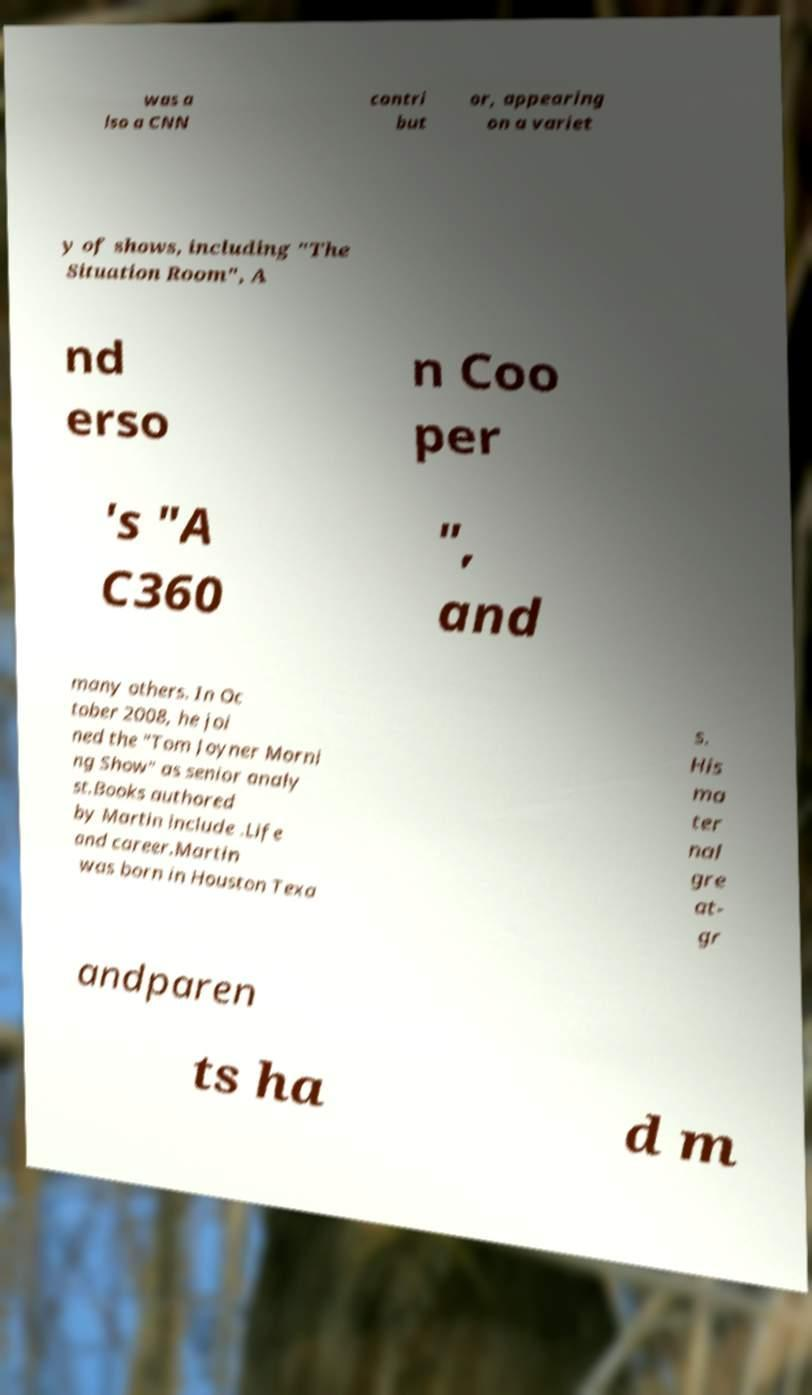Can you accurately transcribe the text from the provided image for me? was a lso a CNN contri but or, appearing on a variet y of shows, including "The Situation Room", A nd erso n Coo per 's "A C360 ", and many others. In Oc tober 2008, he joi ned the "Tom Joyner Morni ng Show" as senior analy st.Books authored by Martin include .Life and career.Martin was born in Houston Texa s. His ma ter nal gre at- gr andparen ts ha d m 